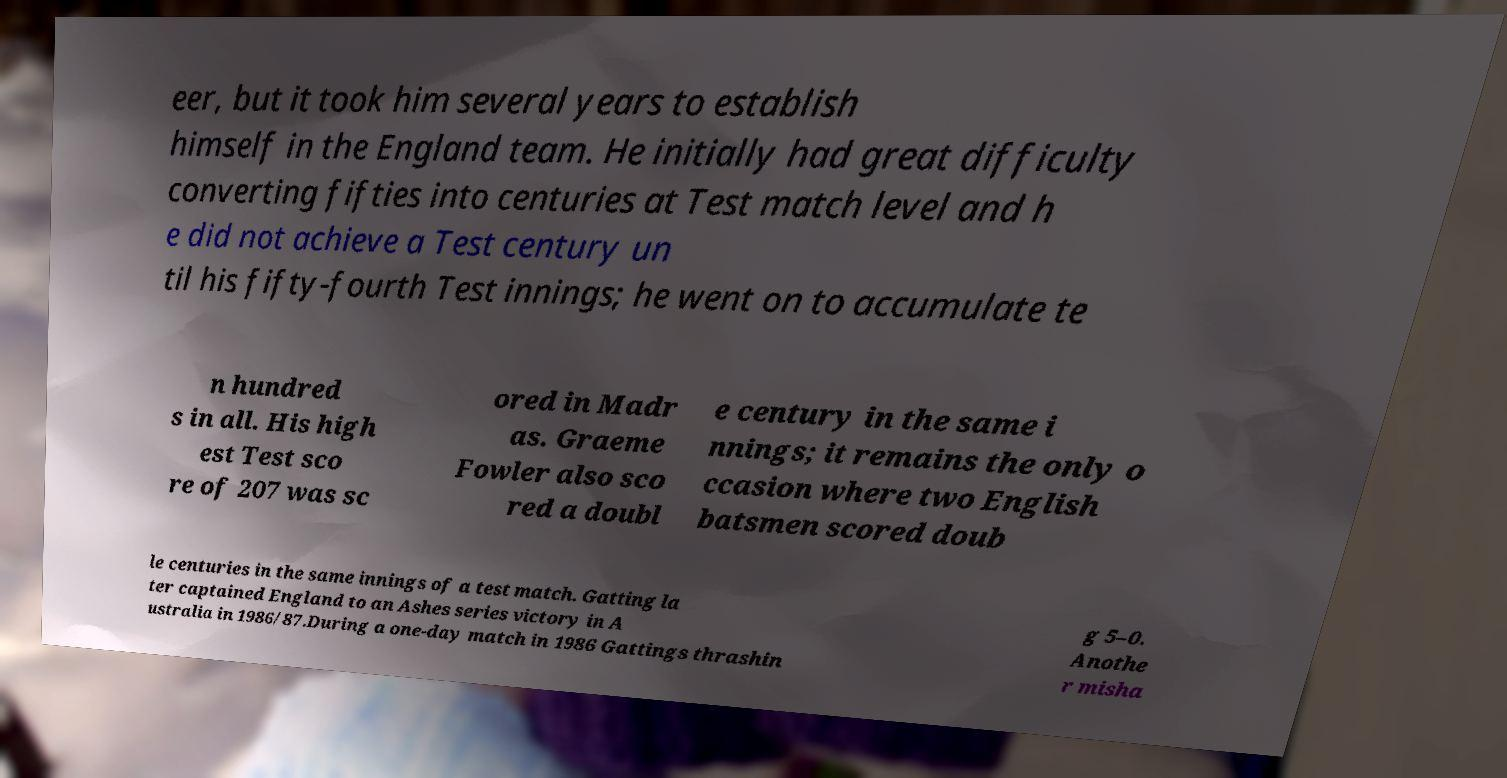Could you assist in decoding the text presented in this image and type it out clearly? eer, but it took him several years to establish himself in the England team. He initially had great difficulty converting fifties into centuries at Test match level and h e did not achieve a Test century un til his fifty-fourth Test innings; he went on to accumulate te n hundred s in all. His high est Test sco re of 207 was sc ored in Madr as. Graeme Fowler also sco red a doubl e century in the same i nnings; it remains the only o ccasion where two English batsmen scored doub le centuries in the same innings of a test match. Gatting la ter captained England to an Ashes series victory in A ustralia in 1986/87.During a one-day match in 1986 Gattings thrashin g 5–0. Anothe r misha 